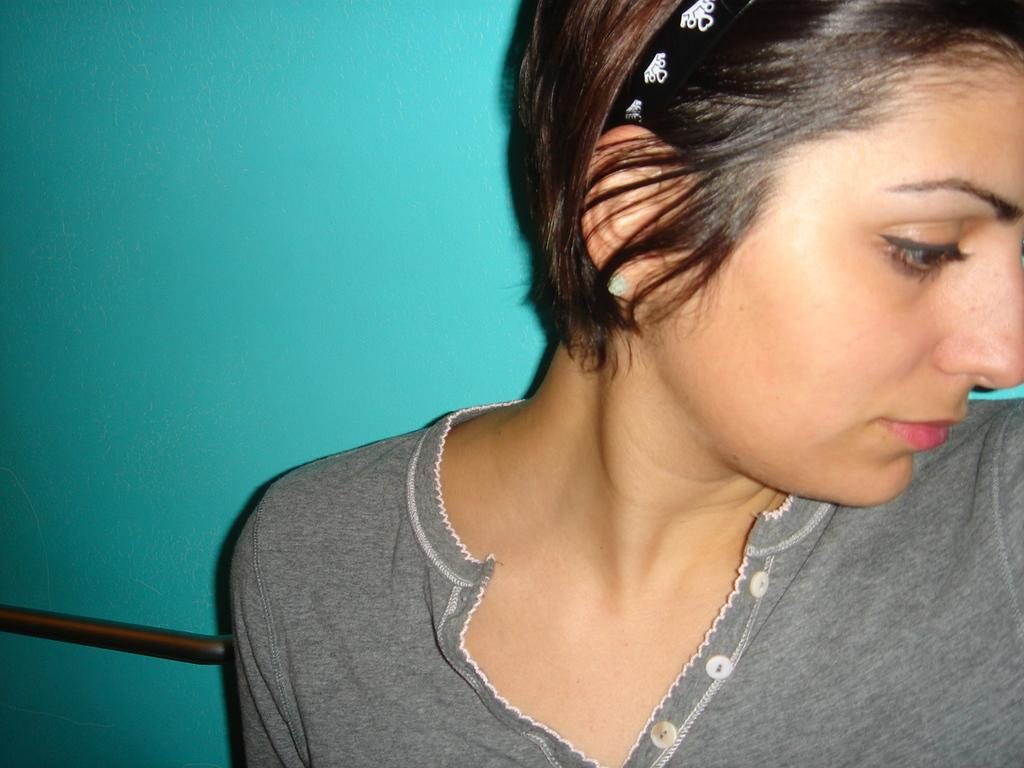Who is the main subject in the image? There is a girl in the image. What is the girl wearing on her upper body? The girl is wearing a grey top. What is the color of the girl's hair? The girl has black hair. Is there any accessory in the girl's hair? Yes, she is wearing a hair band. What can be seen in the background of the image? There is a blue wall in the background. What is attached to the blue wall? A rod is attached to the wall. How many ladybugs are crawling on the girl's grey top in the image? There are no ladybugs present in the image. Can you tell me how the girl is joining the other people in the image? There are no other people present in the image, so it is not possible to determine how she might be joining them. 